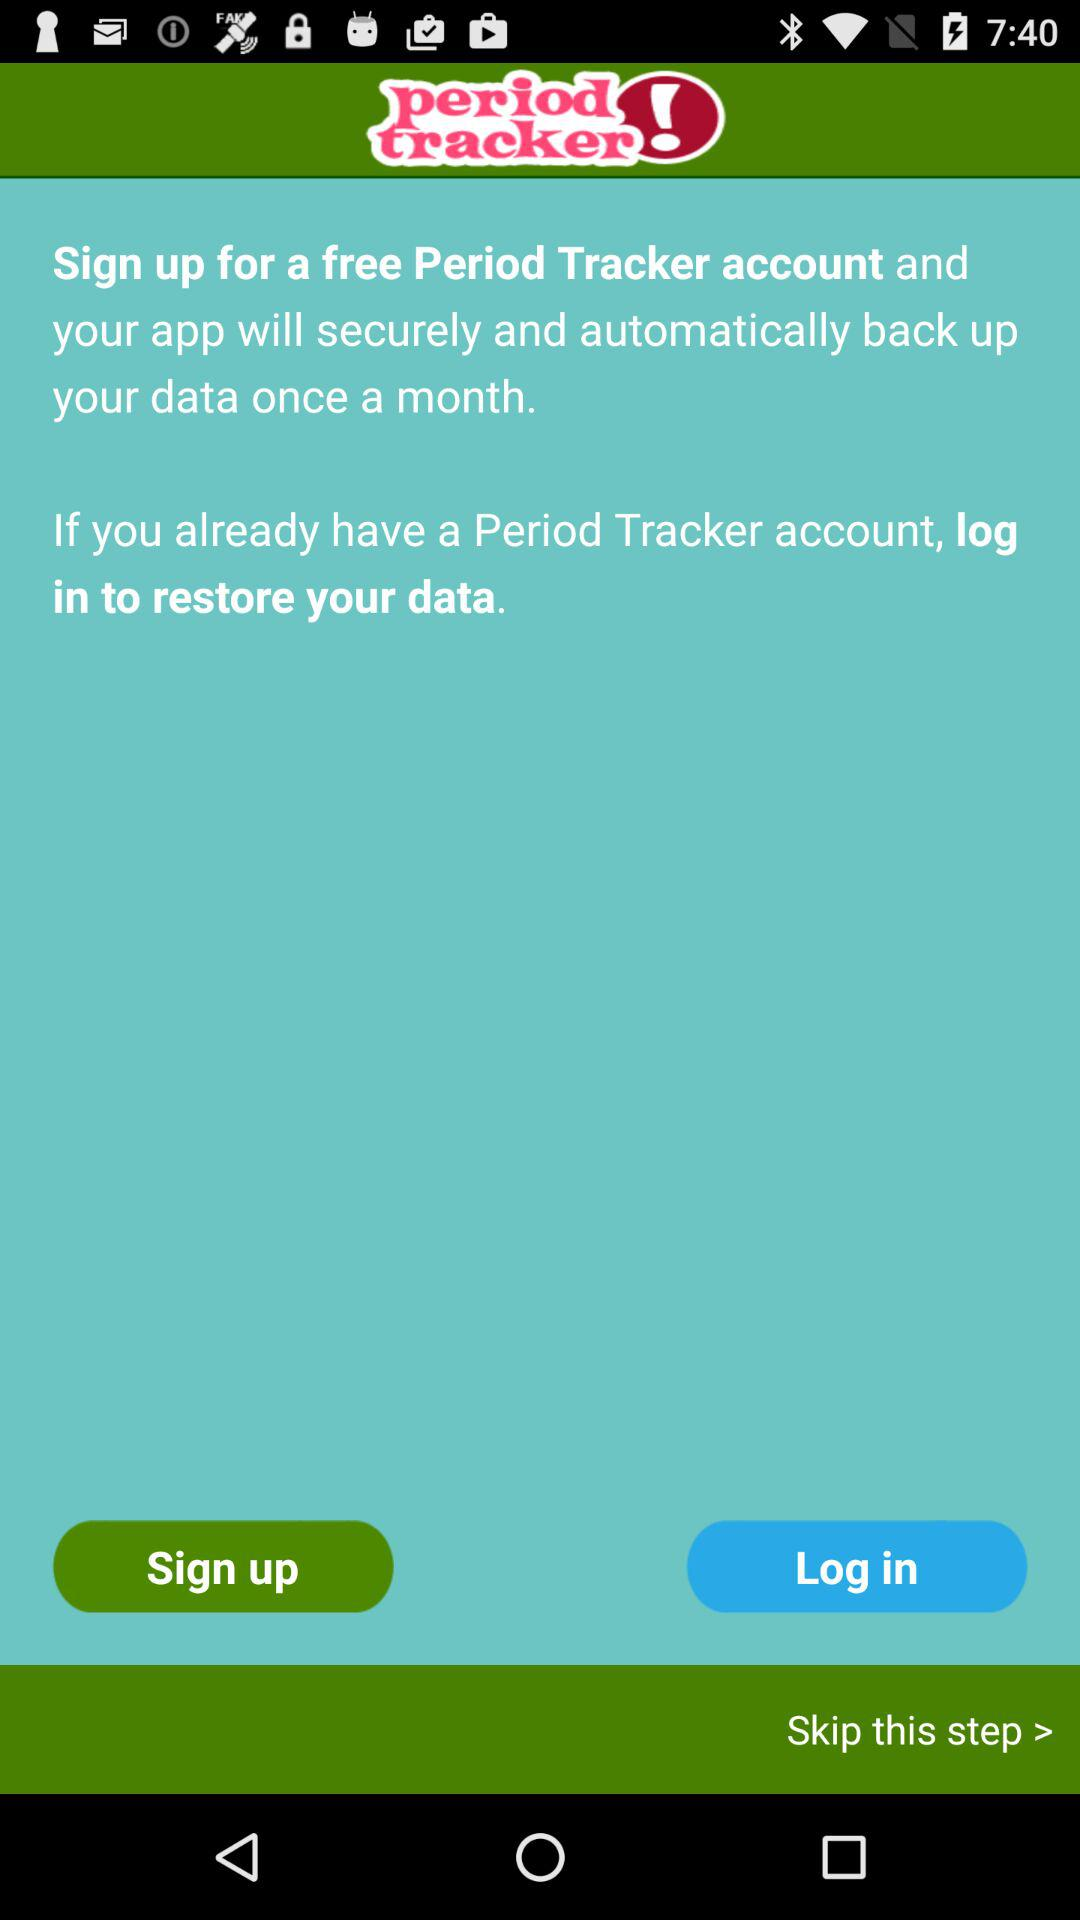What is the name of the application? The name of the application is "period tracker". 